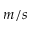<formula> <loc_0><loc_0><loc_500><loc_500>m / s</formula> 